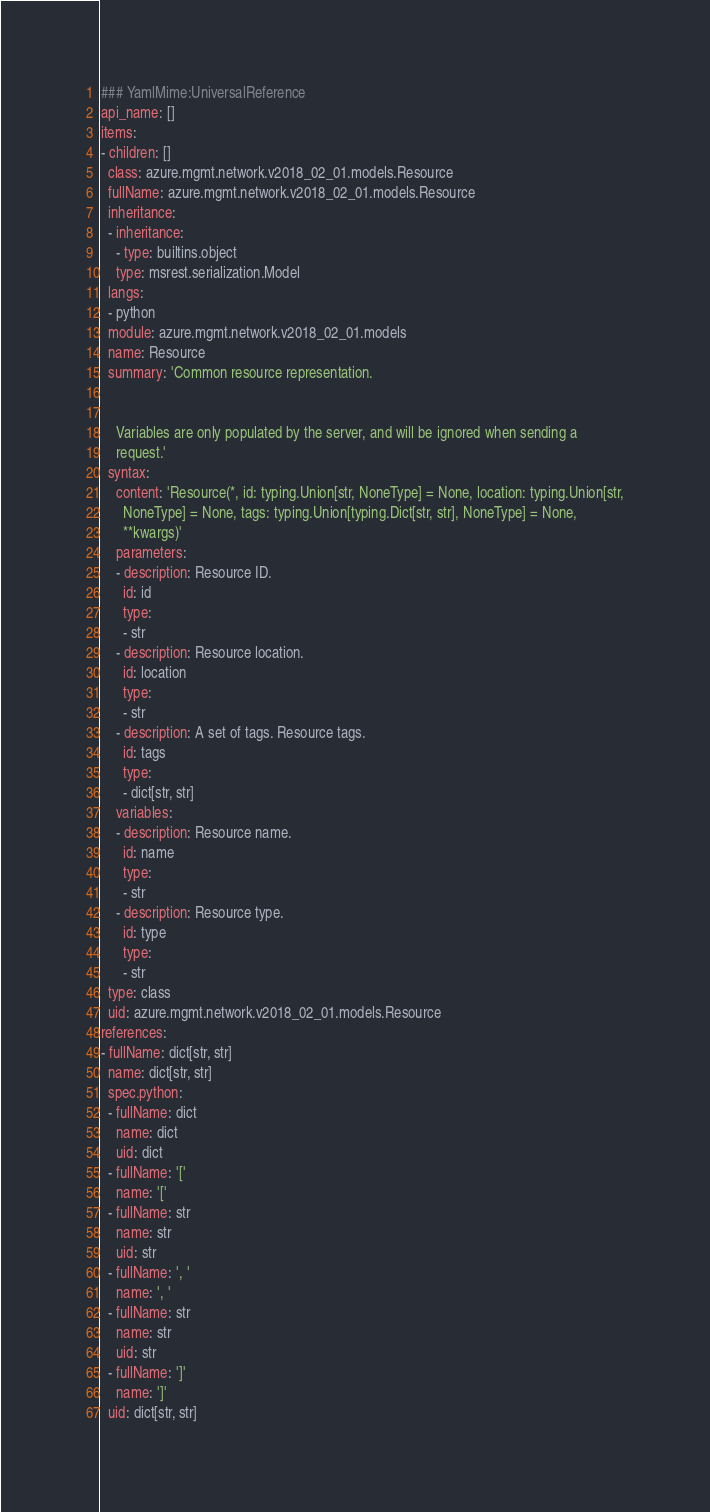<code> <loc_0><loc_0><loc_500><loc_500><_YAML_>### YamlMime:UniversalReference
api_name: []
items:
- children: []
  class: azure.mgmt.network.v2018_02_01.models.Resource
  fullName: azure.mgmt.network.v2018_02_01.models.Resource
  inheritance:
  - inheritance:
    - type: builtins.object
    type: msrest.serialization.Model
  langs:
  - python
  module: azure.mgmt.network.v2018_02_01.models
  name: Resource
  summary: 'Common resource representation.


    Variables are only populated by the server, and will be ignored when sending a
    request.'
  syntax:
    content: 'Resource(*, id: typing.Union[str, NoneType] = None, location: typing.Union[str,
      NoneType] = None, tags: typing.Union[typing.Dict[str, str], NoneType] = None,
      **kwargs)'
    parameters:
    - description: Resource ID.
      id: id
      type:
      - str
    - description: Resource location.
      id: location
      type:
      - str
    - description: A set of tags. Resource tags.
      id: tags
      type:
      - dict[str, str]
    variables:
    - description: Resource name.
      id: name
      type:
      - str
    - description: Resource type.
      id: type
      type:
      - str
  type: class
  uid: azure.mgmt.network.v2018_02_01.models.Resource
references:
- fullName: dict[str, str]
  name: dict[str, str]
  spec.python:
  - fullName: dict
    name: dict
    uid: dict
  - fullName: '['
    name: '['
  - fullName: str
    name: str
    uid: str
  - fullName: ', '
    name: ', '
  - fullName: str
    name: str
    uid: str
  - fullName: ']'
    name: ']'
  uid: dict[str, str]
</code> 